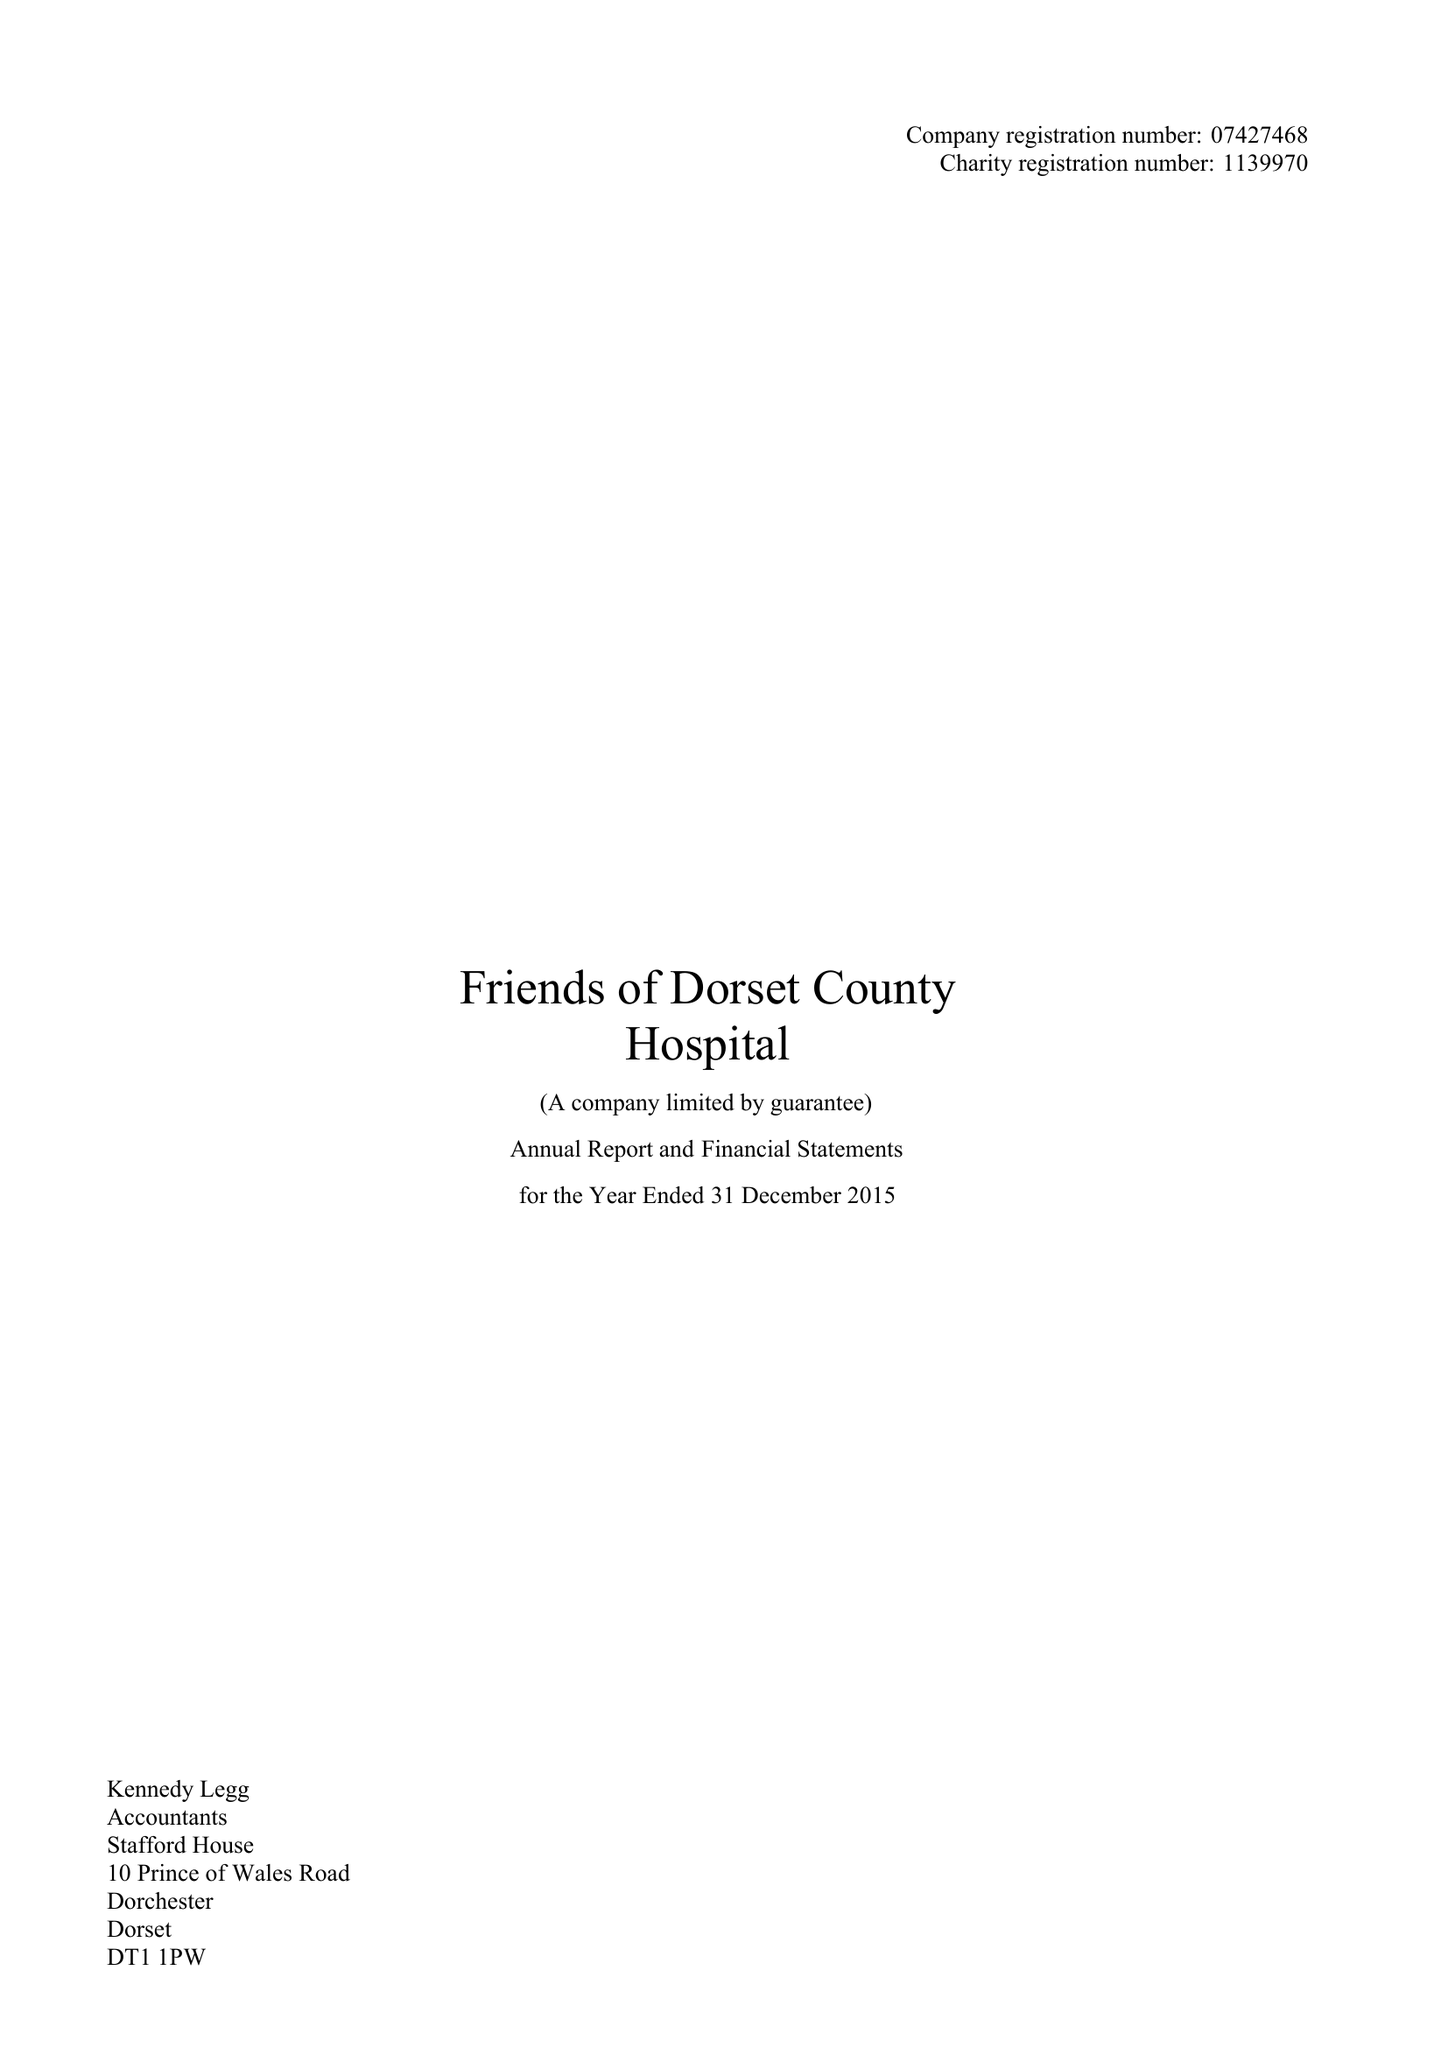What is the value for the report_date?
Answer the question using a single word or phrase. 2015-12-31 